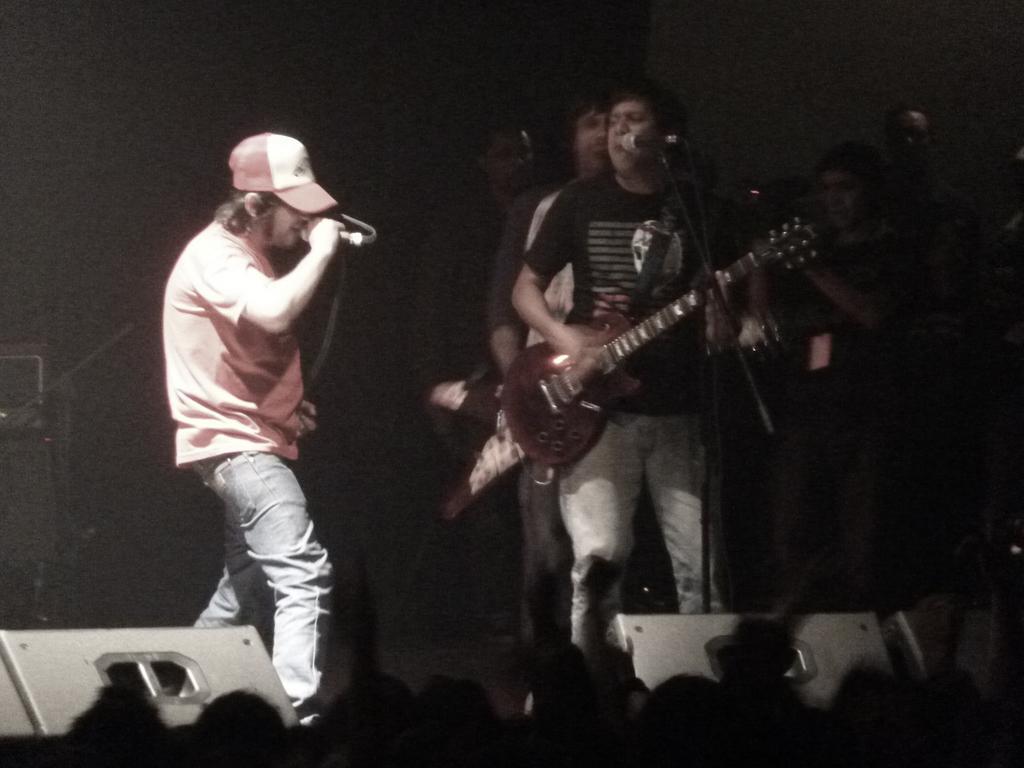In one or two sentences, can you explain what this image depicts? This image is clicked in a concert. There are many people in this image. To the left, the man wearing pink shirt is singing in a mic. To the right, the man wearing black t-shirt is playing guitar. At the bottom, there is a crowd. To the left, there is a speaker. 